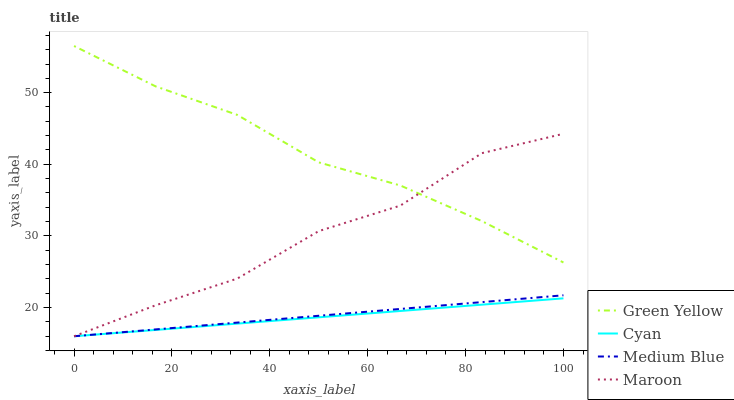Does Cyan have the minimum area under the curve?
Answer yes or no. Yes. Does Green Yellow have the maximum area under the curve?
Answer yes or no. Yes. Does Medium Blue have the minimum area under the curve?
Answer yes or no. No. Does Medium Blue have the maximum area under the curve?
Answer yes or no. No. Is Cyan the smoothest?
Answer yes or no. Yes. Is Maroon the roughest?
Answer yes or no. Yes. Is Green Yellow the smoothest?
Answer yes or no. No. Is Green Yellow the roughest?
Answer yes or no. No. Does Cyan have the lowest value?
Answer yes or no. Yes. Does Green Yellow have the lowest value?
Answer yes or no. No. Does Green Yellow have the highest value?
Answer yes or no. Yes. Does Medium Blue have the highest value?
Answer yes or no. No. Is Cyan less than Green Yellow?
Answer yes or no. Yes. Is Green Yellow greater than Cyan?
Answer yes or no. Yes. Does Cyan intersect Medium Blue?
Answer yes or no. Yes. Is Cyan less than Medium Blue?
Answer yes or no. No. Is Cyan greater than Medium Blue?
Answer yes or no. No. Does Cyan intersect Green Yellow?
Answer yes or no. No. 